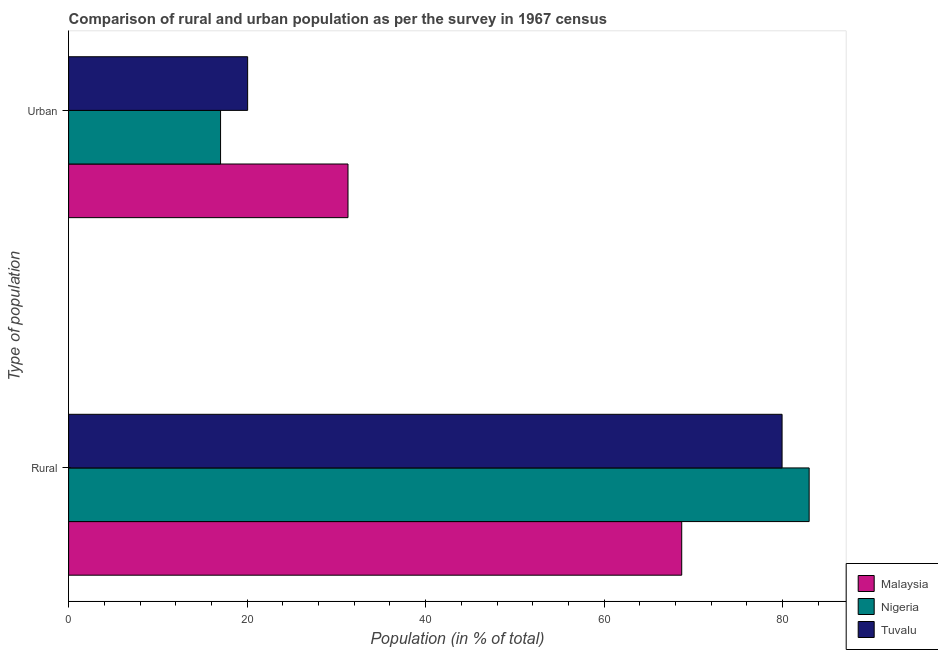Are the number of bars per tick equal to the number of legend labels?
Make the answer very short. Yes. How many bars are there on the 2nd tick from the top?
Keep it short and to the point. 3. How many bars are there on the 1st tick from the bottom?
Provide a short and direct response. 3. What is the label of the 1st group of bars from the top?
Your response must be concise. Urban. What is the urban population in Tuvalu?
Provide a succinct answer. 20.06. Across all countries, what is the maximum urban population?
Provide a short and direct response. 31.3. Across all countries, what is the minimum rural population?
Provide a short and direct response. 68.7. In which country was the rural population maximum?
Offer a very short reply. Nigeria. In which country was the rural population minimum?
Offer a very short reply. Malaysia. What is the total rural population in the graph?
Your response must be concise. 231.61. What is the difference between the urban population in Malaysia and that in Nigeria?
Ensure brevity in your answer.  14.28. What is the difference between the rural population in Malaysia and the urban population in Tuvalu?
Your answer should be very brief. 48.63. What is the average urban population per country?
Ensure brevity in your answer.  22.8. What is the difference between the rural population and urban population in Nigeria?
Your response must be concise. 65.95. What is the ratio of the rural population in Tuvalu to that in Nigeria?
Give a very brief answer. 0.96. What does the 1st bar from the top in Rural represents?
Your answer should be very brief. Tuvalu. What does the 3rd bar from the bottom in Rural represents?
Ensure brevity in your answer.  Tuvalu. How many bars are there?
Offer a very short reply. 6. What is the difference between two consecutive major ticks on the X-axis?
Your answer should be compact. 20. Does the graph contain grids?
Your response must be concise. No. Where does the legend appear in the graph?
Make the answer very short. Bottom right. How many legend labels are there?
Your answer should be very brief. 3. How are the legend labels stacked?
Offer a terse response. Vertical. What is the title of the graph?
Provide a short and direct response. Comparison of rural and urban population as per the survey in 1967 census. Does "High income: nonOECD" appear as one of the legend labels in the graph?
Keep it short and to the point. No. What is the label or title of the X-axis?
Provide a short and direct response. Population (in % of total). What is the label or title of the Y-axis?
Provide a short and direct response. Type of population. What is the Population (in % of total) in Malaysia in Rural?
Give a very brief answer. 68.7. What is the Population (in % of total) of Nigeria in Rural?
Make the answer very short. 82.97. What is the Population (in % of total) of Tuvalu in Rural?
Your answer should be very brief. 79.94. What is the Population (in % of total) in Malaysia in Urban?
Your response must be concise. 31.3. What is the Population (in % of total) of Nigeria in Urban?
Offer a terse response. 17.03. What is the Population (in % of total) of Tuvalu in Urban?
Offer a very short reply. 20.06. Across all Type of population, what is the maximum Population (in % of total) of Malaysia?
Make the answer very short. 68.7. Across all Type of population, what is the maximum Population (in % of total) of Nigeria?
Make the answer very short. 82.97. Across all Type of population, what is the maximum Population (in % of total) of Tuvalu?
Provide a succinct answer. 79.94. Across all Type of population, what is the minimum Population (in % of total) of Malaysia?
Give a very brief answer. 31.3. Across all Type of population, what is the minimum Population (in % of total) in Nigeria?
Offer a very short reply. 17.03. Across all Type of population, what is the minimum Population (in % of total) in Tuvalu?
Your answer should be compact. 20.06. What is the total Population (in % of total) of Tuvalu in the graph?
Offer a very short reply. 100. What is the difference between the Population (in % of total) of Malaysia in Rural and that in Urban?
Offer a very short reply. 37.39. What is the difference between the Population (in % of total) of Nigeria in Rural and that in Urban?
Your answer should be compact. 65.95. What is the difference between the Population (in % of total) in Tuvalu in Rural and that in Urban?
Make the answer very short. 59.88. What is the difference between the Population (in % of total) of Malaysia in Rural and the Population (in % of total) of Nigeria in Urban?
Offer a terse response. 51.67. What is the difference between the Population (in % of total) of Malaysia in Rural and the Population (in % of total) of Tuvalu in Urban?
Offer a terse response. 48.63. What is the difference between the Population (in % of total) in Nigeria in Rural and the Population (in % of total) in Tuvalu in Urban?
Your answer should be very brief. 62.91. What is the average Population (in % of total) in Nigeria per Type of population?
Provide a succinct answer. 50. What is the average Population (in % of total) of Tuvalu per Type of population?
Provide a short and direct response. 50. What is the difference between the Population (in % of total) in Malaysia and Population (in % of total) in Nigeria in Rural?
Your answer should be compact. -14.28. What is the difference between the Population (in % of total) in Malaysia and Population (in % of total) in Tuvalu in Rural?
Provide a short and direct response. -11.24. What is the difference between the Population (in % of total) in Nigeria and Population (in % of total) in Tuvalu in Rural?
Keep it short and to the point. 3.03. What is the difference between the Population (in % of total) of Malaysia and Population (in % of total) of Nigeria in Urban?
Your response must be concise. 14.28. What is the difference between the Population (in % of total) of Malaysia and Population (in % of total) of Tuvalu in Urban?
Make the answer very short. 11.24. What is the difference between the Population (in % of total) in Nigeria and Population (in % of total) in Tuvalu in Urban?
Ensure brevity in your answer.  -3.03. What is the ratio of the Population (in % of total) of Malaysia in Rural to that in Urban?
Offer a very short reply. 2.19. What is the ratio of the Population (in % of total) in Nigeria in Rural to that in Urban?
Your answer should be very brief. 4.87. What is the ratio of the Population (in % of total) in Tuvalu in Rural to that in Urban?
Give a very brief answer. 3.98. What is the difference between the highest and the second highest Population (in % of total) of Malaysia?
Provide a short and direct response. 37.39. What is the difference between the highest and the second highest Population (in % of total) of Nigeria?
Ensure brevity in your answer.  65.95. What is the difference between the highest and the second highest Population (in % of total) of Tuvalu?
Provide a short and direct response. 59.88. What is the difference between the highest and the lowest Population (in % of total) in Malaysia?
Offer a terse response. 37.39. What is the difference between the highest and the lowest Population (in % of total) of Nigeria?
Ensure brevity in your answer.  65.95. What is the difference between the highest and the lowest Population (in % of total) in Tuvalu?
Offer a terse response. 59.88. 